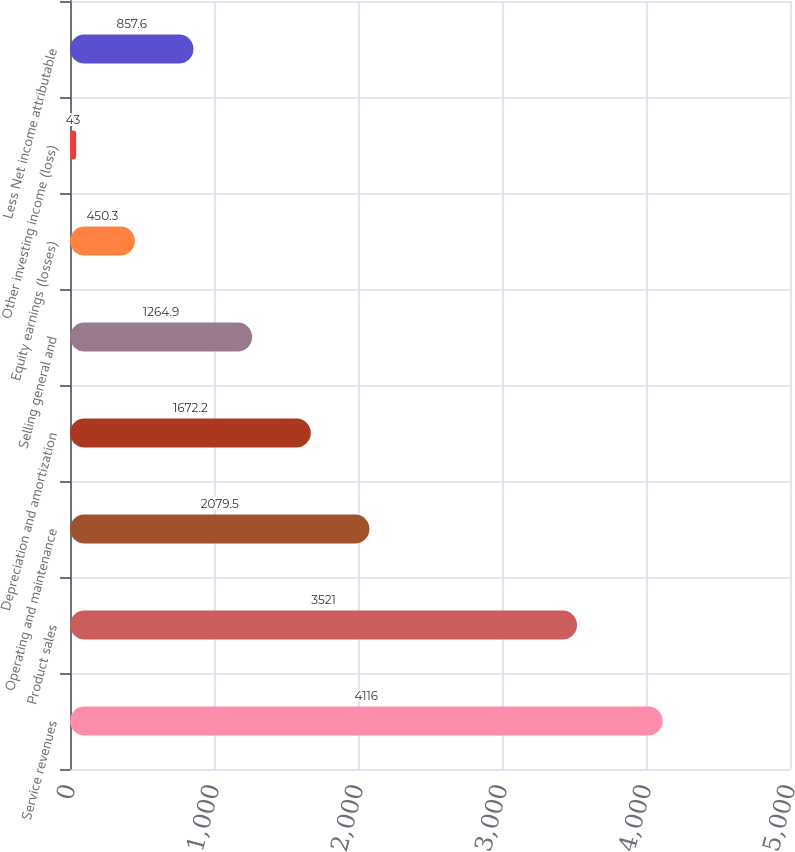Convert chart. <chart><loc_0><loc_0><loc_500><loc_500><bar_chart><fcel>Service revenues<fcel>Product sales<fcel>Operating and maintenance<fcel>Depreciation and amortization<fcel>Selling general and<fcel>Equity earnings (losses)<fcel>Other investing income (loss)<fcel>Less Net income attributable<nl><fcel>4116<fcel>3521<fcel>2079.5<fcel>1672.2<fcel>1264.9<fcel>450.3<fcel>43<fcel>857.6<nl></chart> 